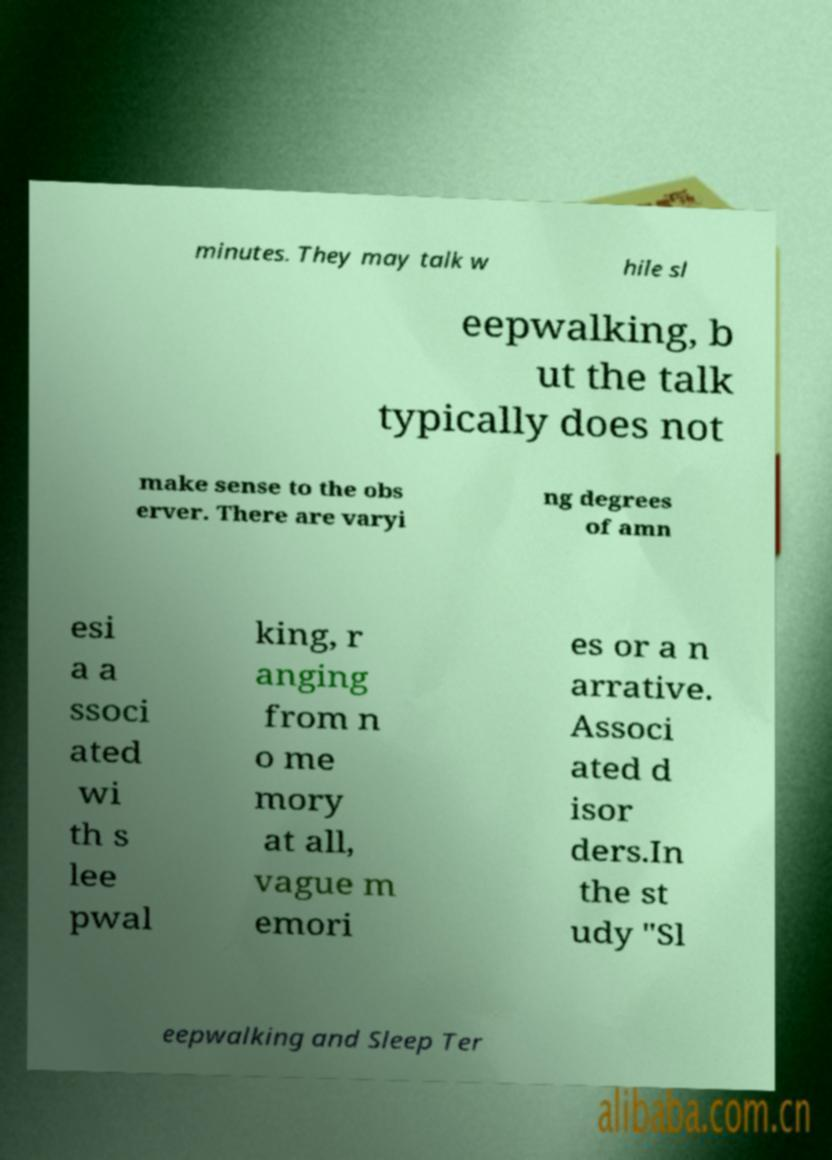Please read and relay the text visible in this image. What does it say? minutes. They may talk w hile sl eepwalking, b ut the talk typically does not make sense to the obs erver. There are varyi ng degrees of amn esi a a ssoci ated wi th s lee pwal king, r anging from n o me mory at all, vague m emori es or a n arrative. Associ ated d isor ders.In the st udy "Sl eepwalking and Sleep Ter 